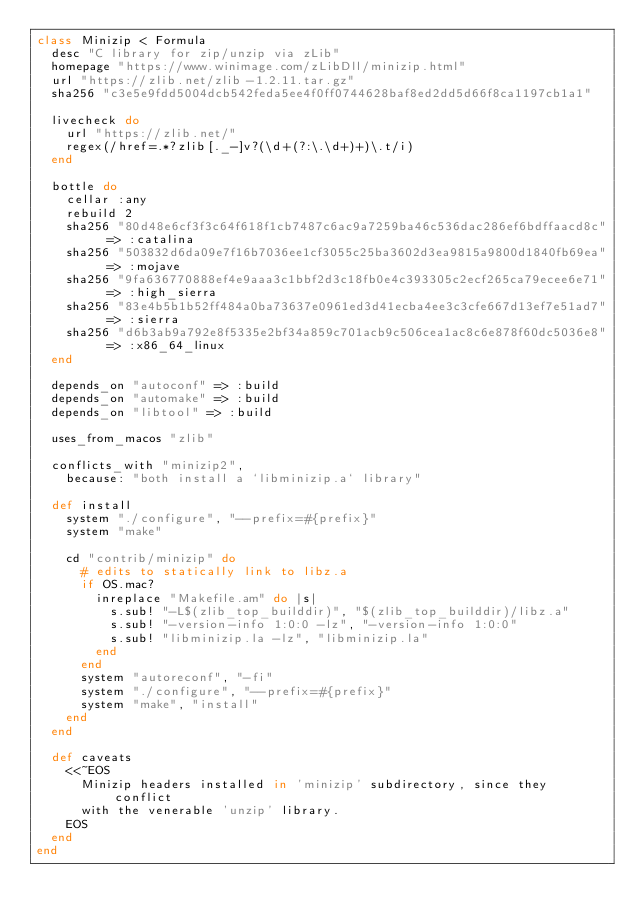Convert code to text. <code><loc_0><loc_0><loc_500><loc_500><_Ruby_>class Minizip < Formula
  desc "C library for zip/unzip via zLib"
  homepage "https://www.winimage.com/zLibDll/minizip.html"
  url "https://zlib.net/zlib-1.2.11.tar.gz"
  sha256 "c3e5e9fdd5004dcb542feda5ee4f0ff0744628baf8ed2dd5d66f8ca1197cb1a1"

  livecheck do
    url "https://zlib.net/"
    regex(/href=.*?zlib[._-]v?(\d+(?:\.\d+)+)\.t/i)
  end

  bottle do
    cellar :any
    rebuild 2
    sha256 "80d48e6cf3f3c64f618f1cb7487c6ac9a7259ba46c536dac286ef6bdffaacd8c" => :catalina
    sha256 "503832d6da09e7f16b7036ee1cf3055c25ba3602d3ea9815a9800d1840fb69ea" => :mojave
    sha256 "9fa636770888ef4e9aaa3c1bbf2d3c18fb0e4c393305c2ecf265ca79ecee6e71" => :high_sierra
    sha256 "83e4b5b1b52ff484a0ba73637e0961ed3d41ecba4ee3c3cfe667d13ef7e51ad7" => :sierra
    sha256 "d6b3ab9a792e8f5335e2bf34a859c701acb9c506cea1ac8c6e878f60dc5036e8" => :x86_64_linux
  end

  depends_on "autoconf" => :build
  depends_on "automake" => :build
  depends_on "libtool" => :build

  uses_from_macos "zlib"

  conflicts_with "minizip2",
    because: "both install a `libminizip.a` library"

  def install
    system "./configure", "--prefix=#{prefix}"
    system "make"

    cd "contrib/minizip" do
      # edits to statically link to libz.a
      if OS.mac?
        inreplace "Makefile.am" do |s|
          s.sub! "-L$(zlib_top_builddir)", "$(zlib_top_builddir)/libz.a"
          s.sub! "-version-info 1:0:0 -lz", "-version-info 1:0:0"
          s.sub! "libminizip.la -lz", "libminizip.la"
        end
      end
      system "autoreconf", "-fi"
      system "./configure", "--prefix=#{prefix}"
      system "make", "install"
    end
  end

  def caveats
    <<~EOS
      Minizip headers installed in 'minizip' subdirectory, since they conflict
      with the venerable 'unzip' library.
    EOS
  end
end
</code> 